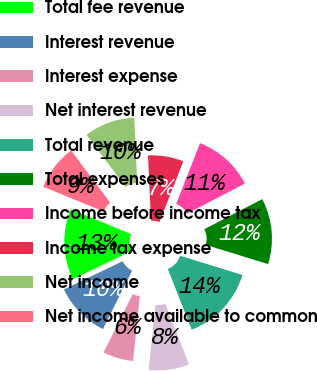Convert chart. <chart><loc_0><loc_0><loc_500><loc_500><pie_chart><fcel>Total fee revenue<fcel>Interest revenue<fcel>Interest expense<fcel>Net interest revenue<fcel>Total revenue<fcel>Total expenses<fcel>Income before income tax<fcel>Income tax expense<fcel>Net income<fcel>Net income available to common<nl><fcel>13.33%<fcel>10.48%<fcel>5.71%<fcel>7.62%<fcel>14.29%<fcel>12.38%<fcel>11.43%<fcel>6.67%<fcel>9.52%<fcel>8.57%<nl></chart> 